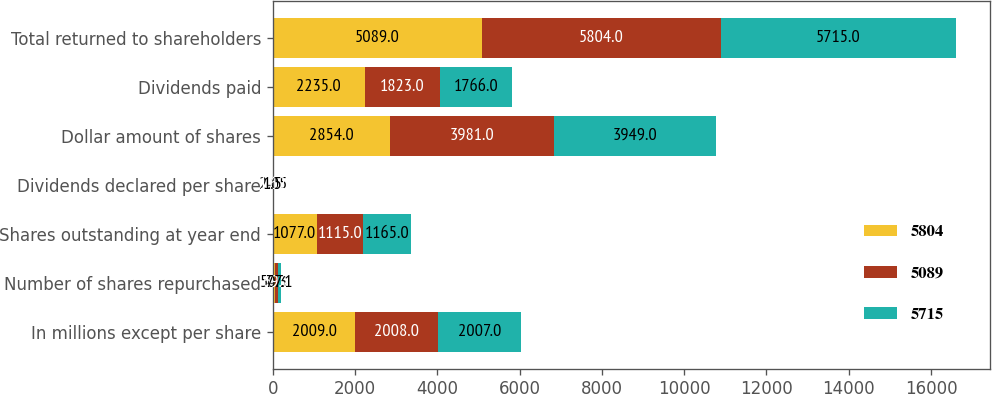Convert chart. <chart><loc_0><loc_0><loc_500><loc_500><stacked_bar_chart><ecel><fcel>In millions except per share<fcel>Number of shares repurchased<fcel>Shares outstanding at year end<fcel>Dividends declared per share<fcel>Dollar amount of shares<fcel>Dividends paid<fcel>Total returned to shareholders<nl><fcel>5804<fcel>2009<fcel>50.3<fcel>1077<fcel>2.05<fcel>2854<fcel>2235<fcel>5089<nl><fcel>5089<fcel>2008<fcel>69.7<fcel>1115<fcel>1.62<fcel>3981<fcel>1823<fcel>5804<nl><fcel>5715<fcel>2007<fcel>77.1<fcel>1165<fcel>1.5<fcel>3949<fcel>1766<fcel>5715<nl></chart> 